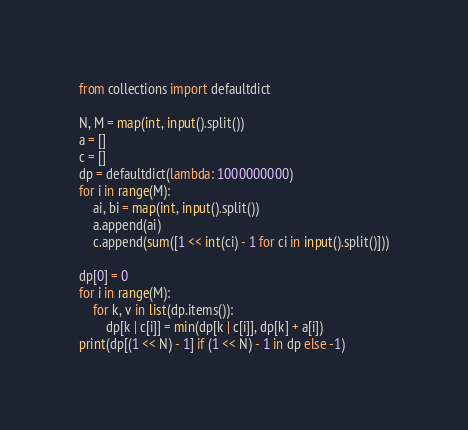<code> <loc_0><loc_0><loc_500><loc_500><_Python_>from collections import defaultdict

N, M = map(int, input().split())
a = []
c = []
dp = defaultdict(lambda: 1000000000)
for i in range(M):
    ai, bi = map(int, input().split())
    a.append(ai)
    c.append(sum([1 << int(ci) - 1 for ci in input().split()]))

dp[0] = 0
for i in range(M):
    for k, v in list(dp.items()):
        dp[k | c[i]] = min(dp[k | c[i]], dp[k] + a[i])
print(dp[(1 << N) - 1] if (1 << N) - 1 in dp else -1)
</code> 